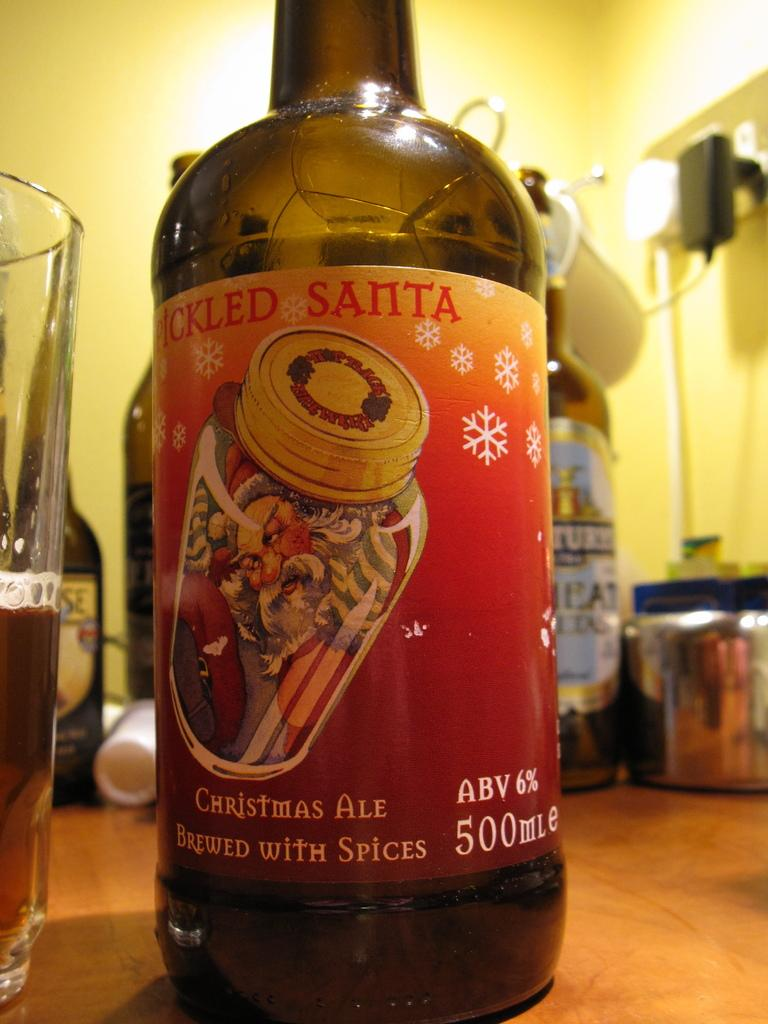Provide a one-sentence caption for the provided image. A bottle of Picked Santa christmas ale sits on a table. 